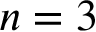<formula> <loc_0><loc_0><loc_500><loc_500>n = 3</formula> 